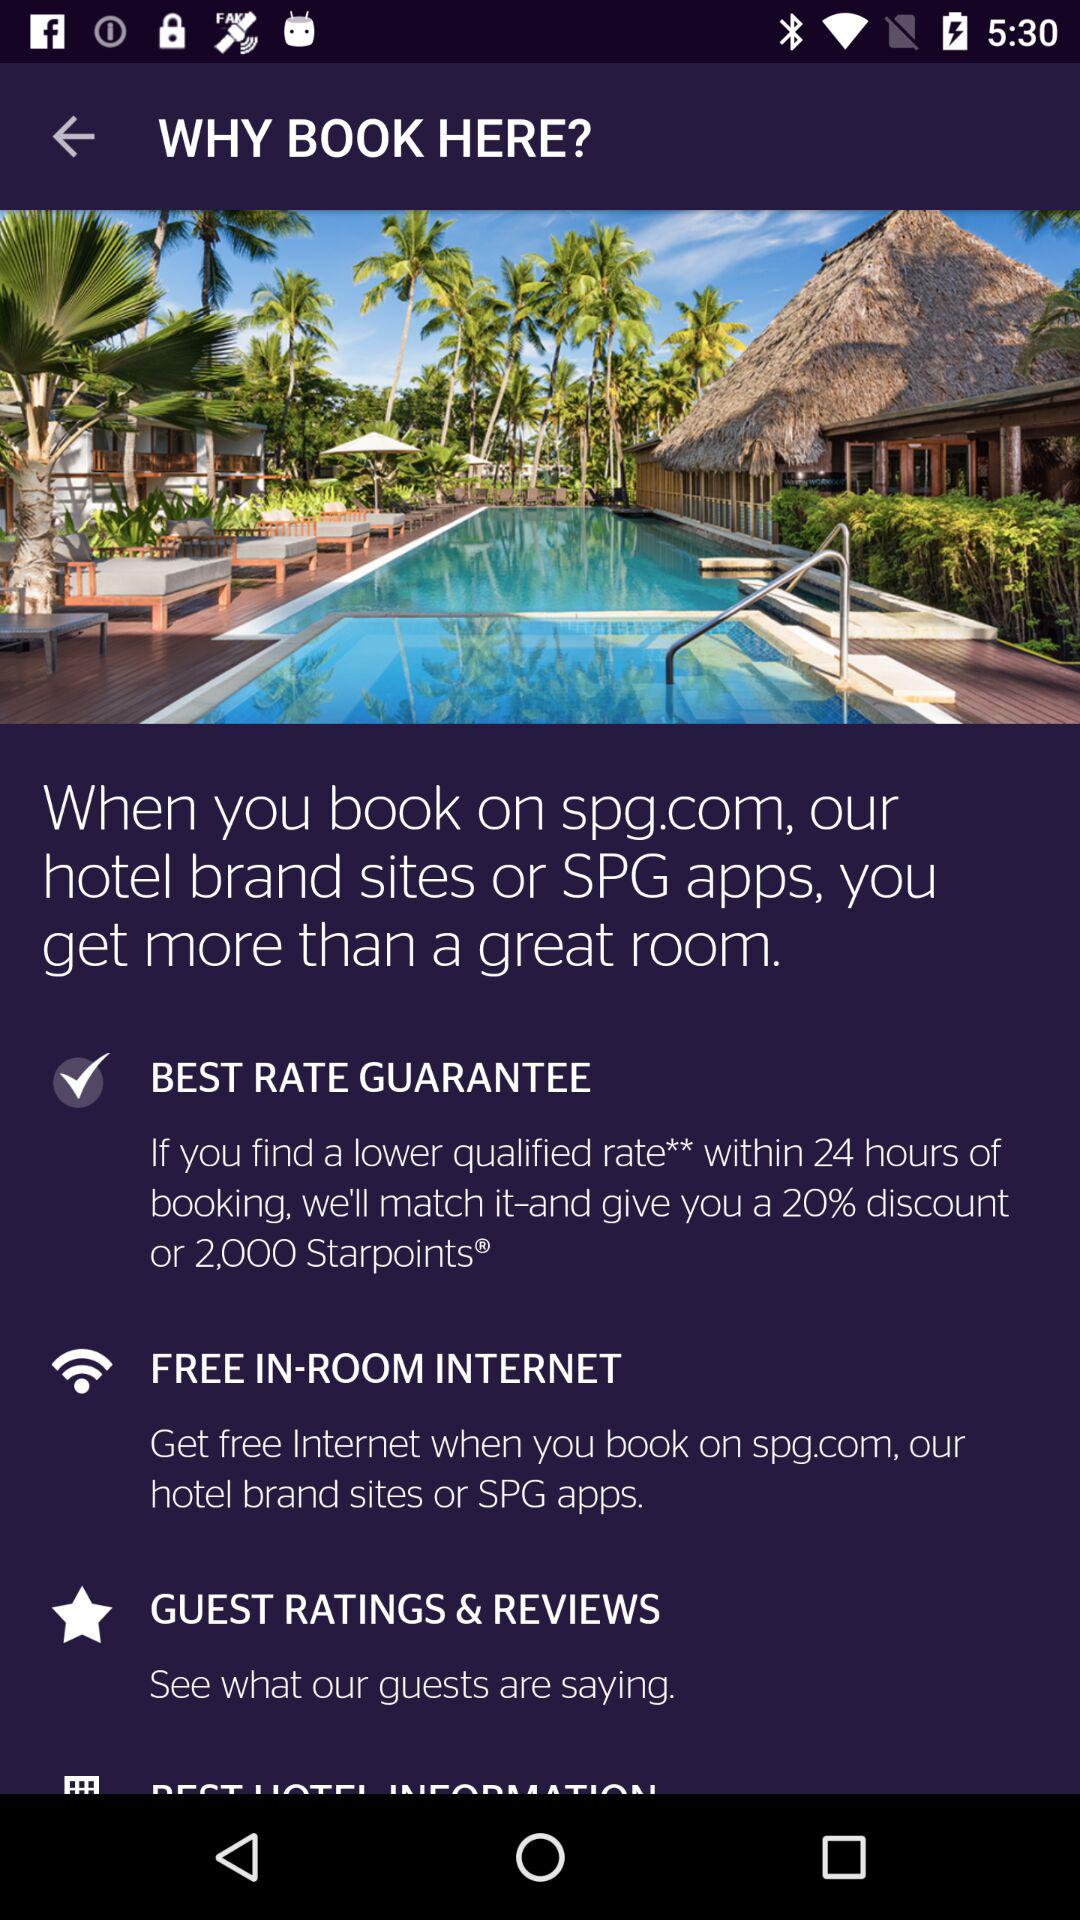What is the application name? The application name is "WHY BOOK HERE?". 